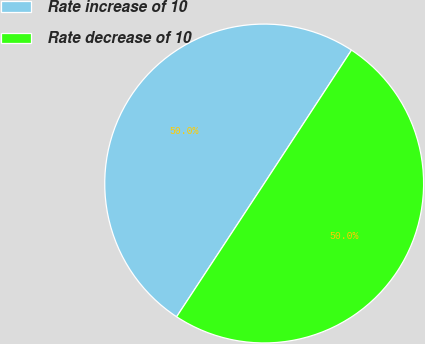<chart> <loc_0><loc_0><loc_500><loc_500><pie_chart><fcel>Rate increase of 10<fcel>Rate decrease of 10<nl><fcel>49.97%<fcel>50.03%<nl></chart> 